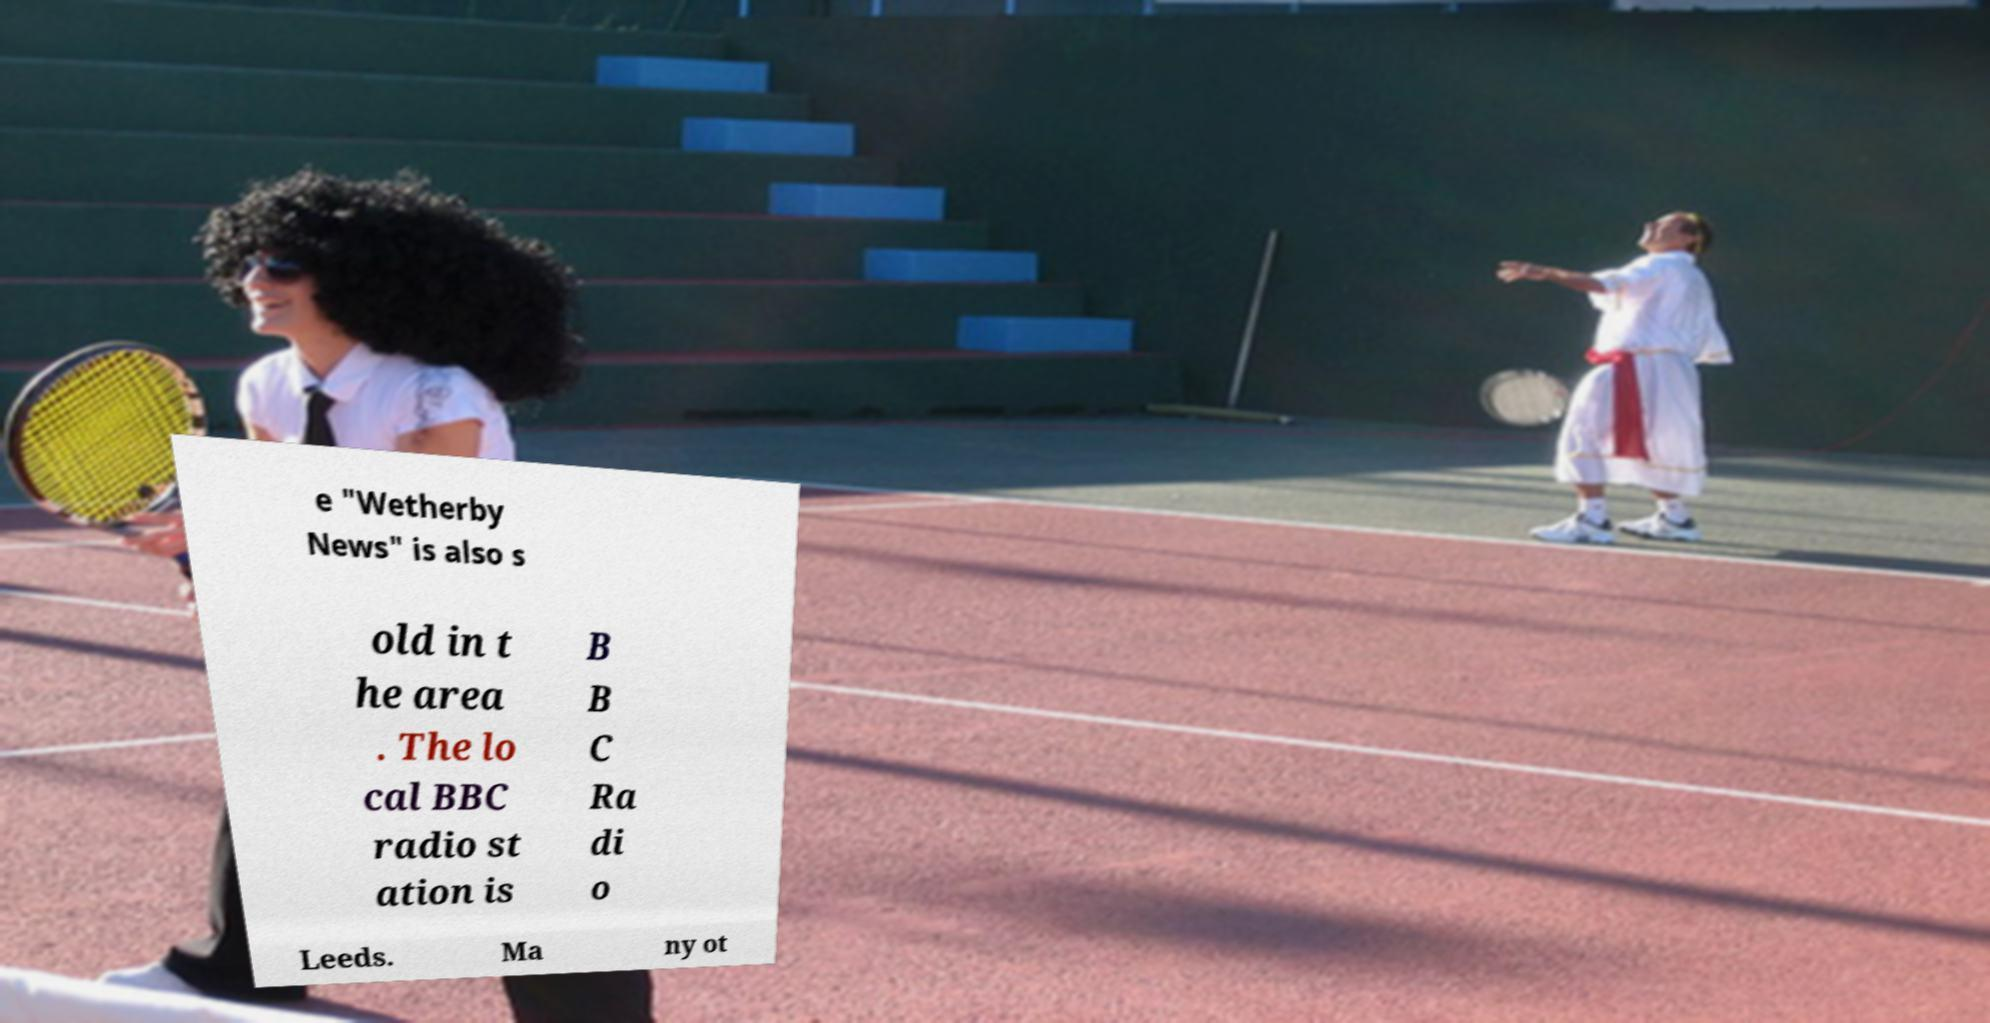Can you read and provide the text displayed in the image?This photo seems to have some interesting text. Can you extract and type it out for me? e "Wetherby News" is also s old in t he area . The lo cal BBC radio st ation is B B C Ra di o Leeds. Ma ny ot 